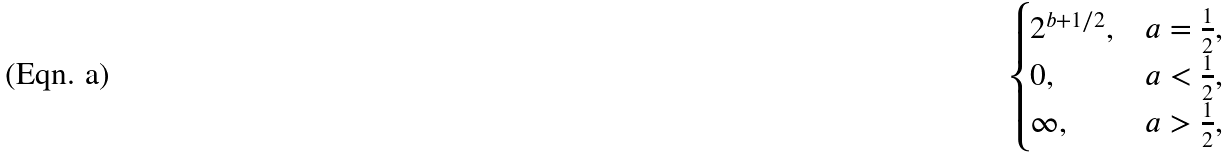<formula> <loc_0><loc_0><loc_500><loc_500>\begin{cases} 2 ^ { b + 1 / 2 } , & a = \frac { 1 } { 2 } , \\ 0 , & a < \frac { 1 } { 2 } , \\ \infty , & a > \frac { 1 } { 2 } , \end{cases}</formula> 